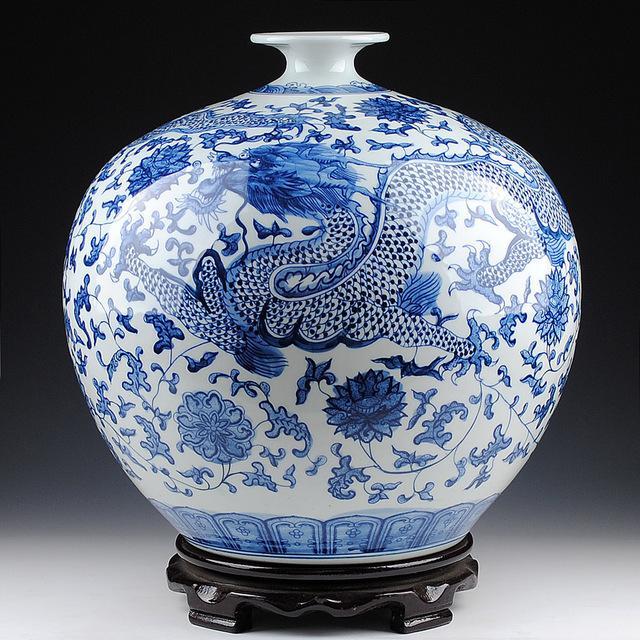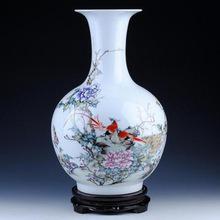The first image is the image on the left, the second image is the image on the right. Assess this claim about the two images: "One ceramic vase features floral motifs and only blue and white colors, and the other vase has a narrow neck with a wider round bottom and includes pink flowers as decoration.". Correct or not? Answer yes or no. Yes. The first image is the image on the left, the second image is the image on the right. Given the left and right images, does the statement "In at least one image there is a all blue and white vase with a circular middle." hold true? Answer yes or no. Yes. 